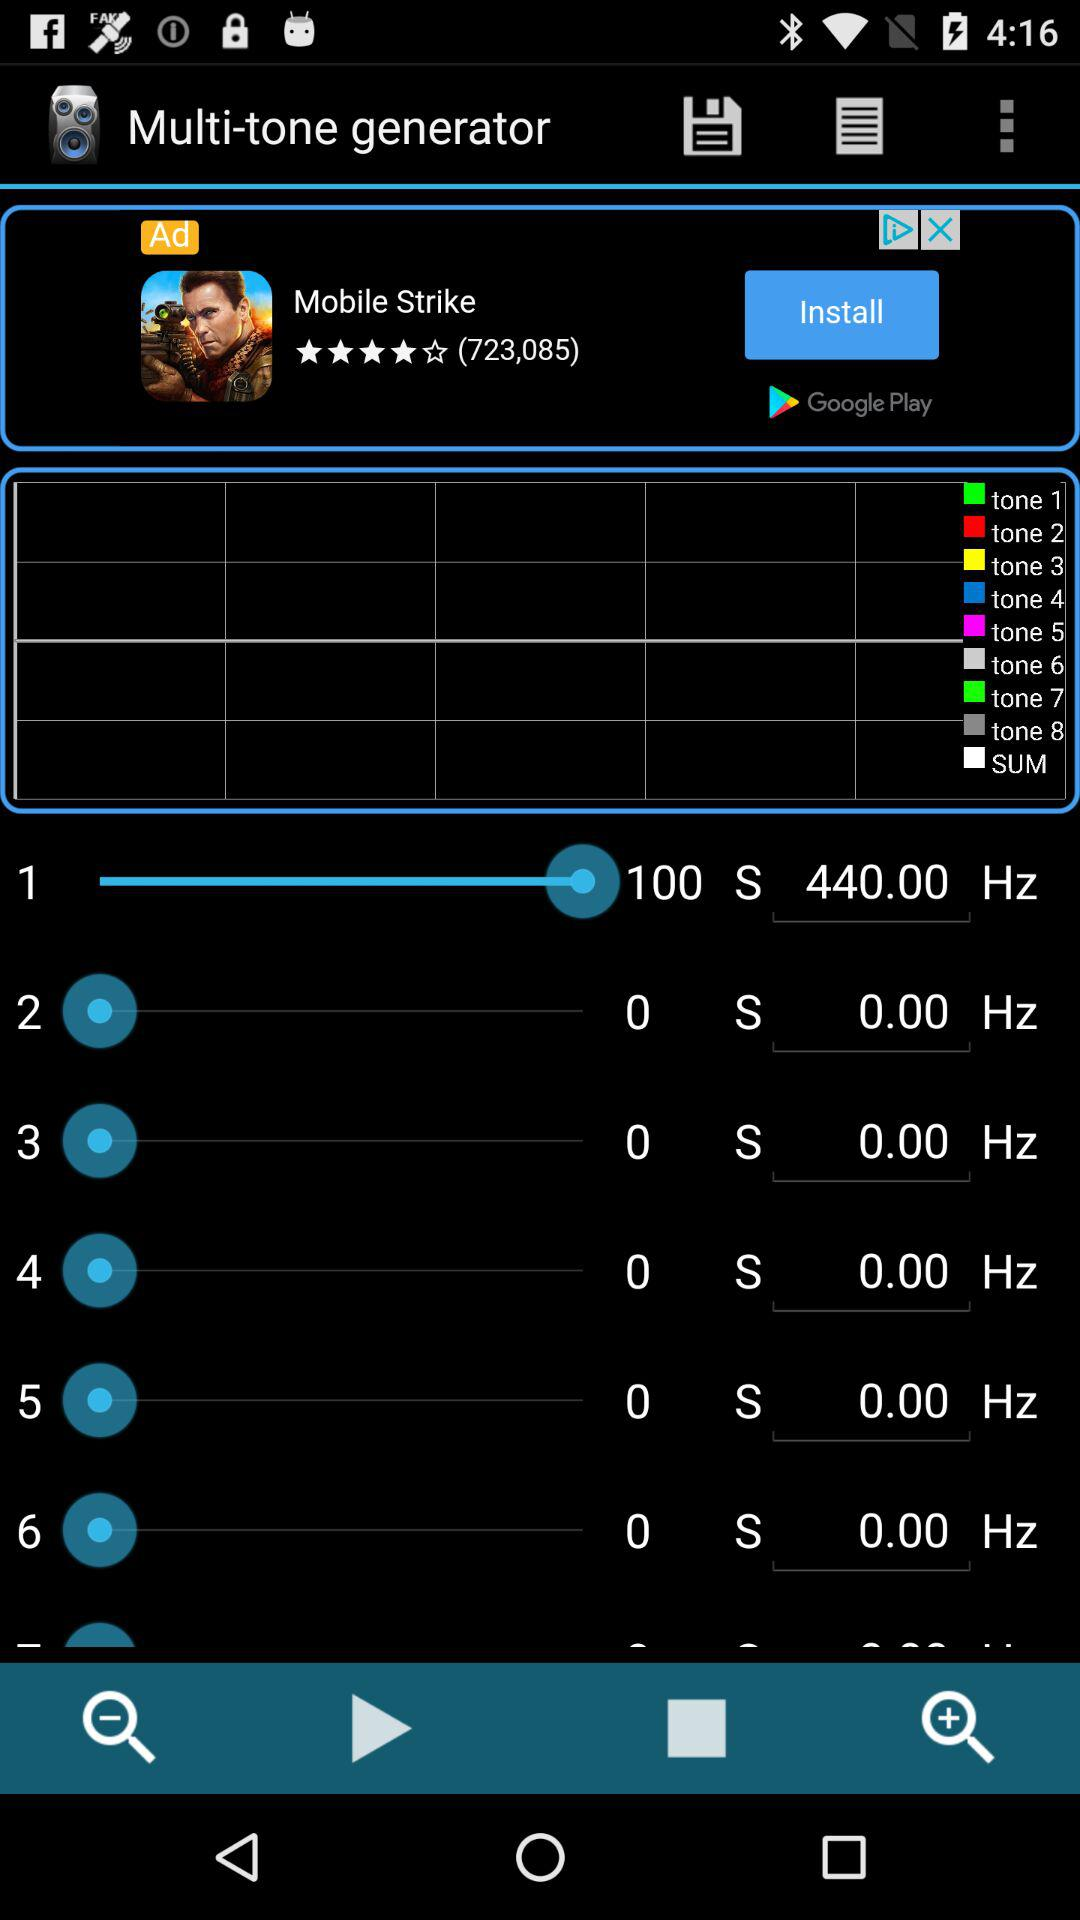What is the level of frequency? The level of frequency is 440.00 Hz. 